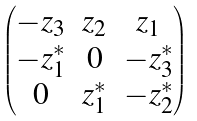<formula> <loc_0><loc_0><loc_500><loc_500>\begin{pmatrix} - z _ { 3 } & z _ { 2 } & z _ { 1 } \\ - z ^ { * } _ { 1 } & 0 & - z ^ { * } _ { 3 } \\ 0 & z ^ { * } _ { 1 } & - z ^ { * } _ { 2 } \end{pmatrix}</formula> 